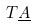<formula> <loc_0><loc_0><loc_500><loc_500>T \underline { A }</formula> 